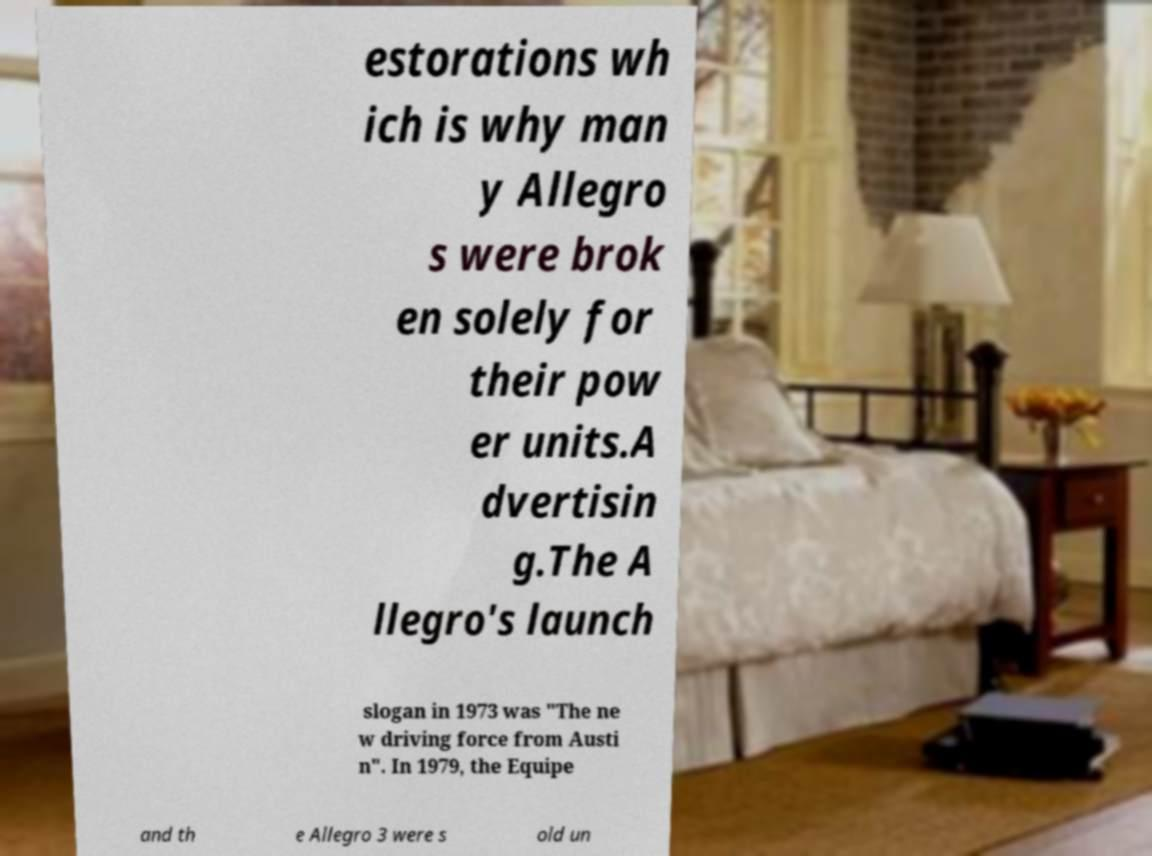What messages or text are displayed in this image? I need them in a readable, typed format. estorations wh ich is why man y Allegro s were brok en solely for their pow er units.A dvertisin g.The A llegro's launch slogan in 1973 was "The ne w driving force from Austi n". In 1979, the Equipe and th e Allegro 3 were s old un 